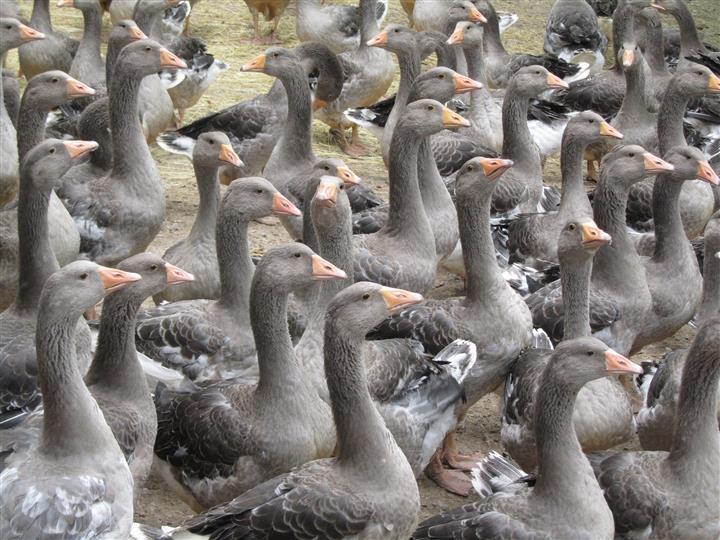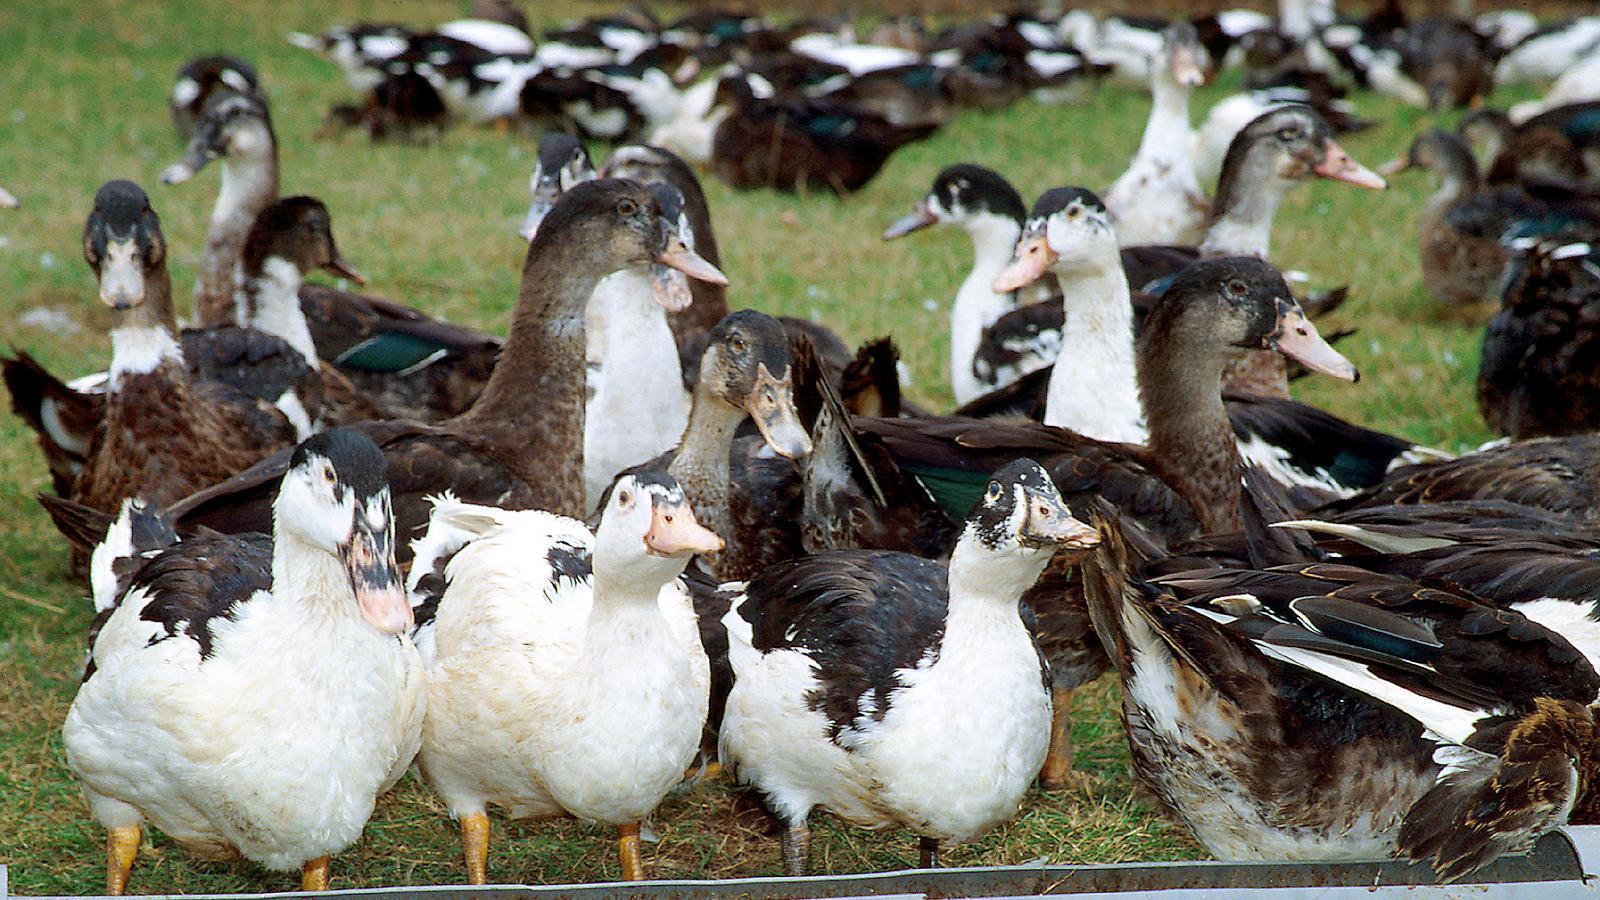The first image is the image on the left, the second image is the image on the right. Assess this claim about the two images: "An image shows a group of water fowl all walking in the same direction.". Correct or not? Answer yes or no. No. The first image is the image on the left, the second image is the image on the right. Assess this claim about the two images: "The right image shows birds standing in grass.". Correct or not? Answer yes or no. Yes. 